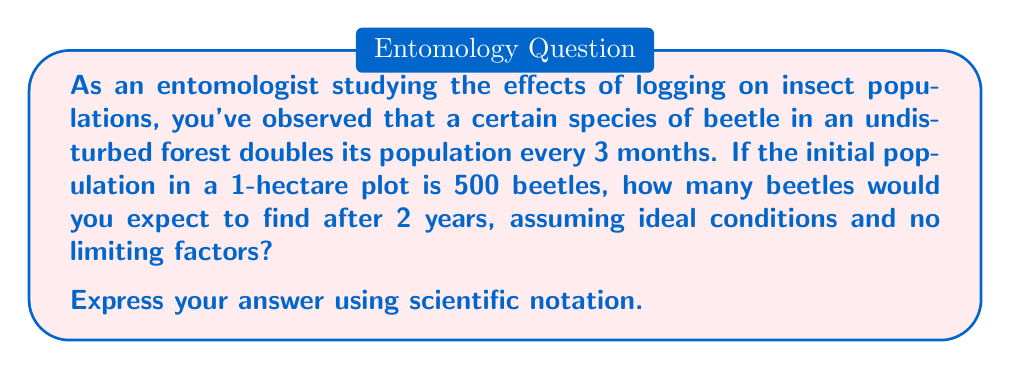Teach me how to tackle this problem. To solve this problem, we need to use the exponential growth formula:

$$A = P(1 + r)^t$$

Where:
$A$ = Final amount
$P$ = Initial population
$r$ = Growth rate
$t$ = Number of time periods

In this case:
$P = 500$ beetles
$r = 1$ (100% growth rate, as the population doubles)
$t = 8$ (2 years = 24 months, which is 8 3-month periods)

Let's break it down step-by-step:

1) First, we need to adjust our formula since the population doubles every period:
   $$A = P(2)^t$$

2) Now, let's plug in our values:
   $$A = 500(2)^8$$

3) Simplify the exponent:
   $$A = 500 \cdot 2^8$$

4) Calculate $2^8$:
   $$2^8 = 256$$

5) Multiply:
   $$A = 500 \cdot 256 = 128,000$$

6) Convert to scientific notation:
   $$A = 1.28 \times 10^5$$

Therefore, after 2 years, we would expect to find $1.28 \times 10^5$ beetles in the 1-hectare plot.
Answer: $1.28 \times 10^5$ beetles 